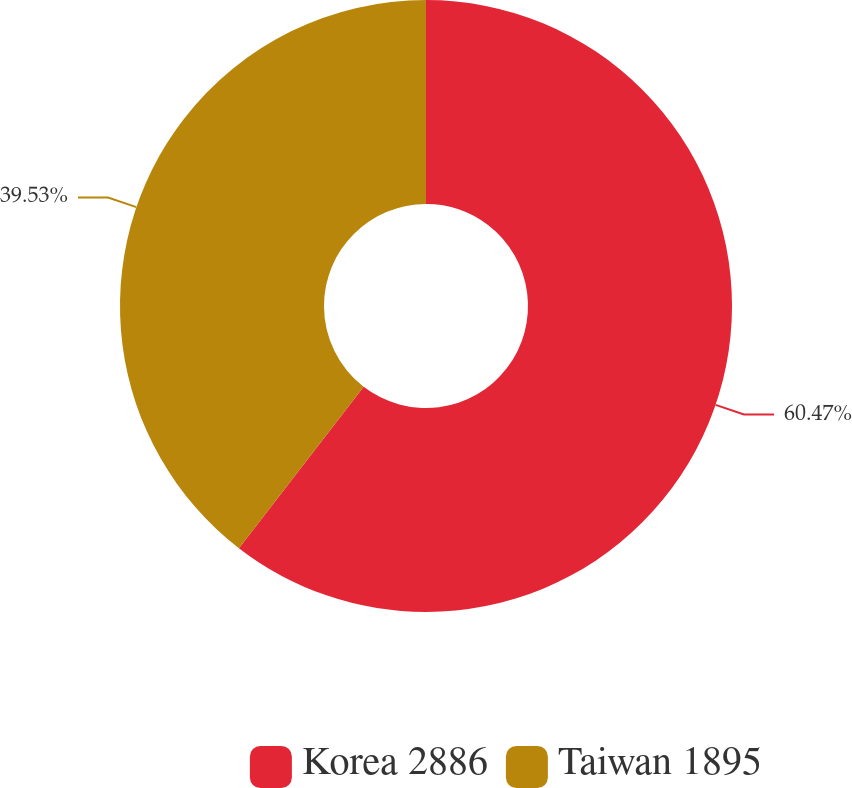<chart> <loc_0><loc_0><loc_500><loc_500><pie_chart><fcel>Korea 2886<fcel>Taiwan 1895<nl><fcel>60.47%<fcel>39.53%<nl></chart> 